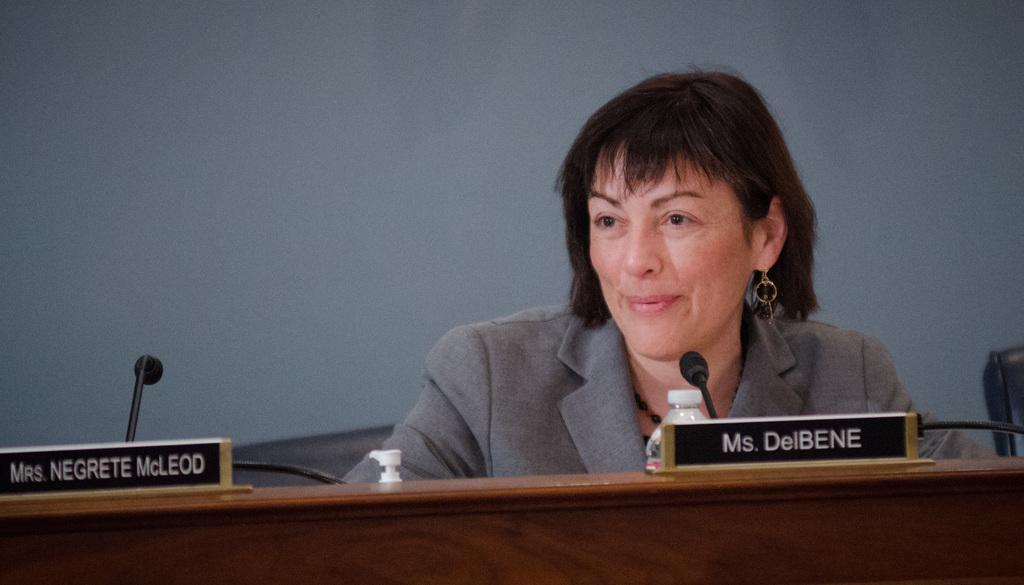What is the woman in the image doing? The woman is sitting and smiling in the image. What is the woman wearing? The woman is wearing a suit. What can be seen on the table in the image? There are name boards, microphones (mikes), and a bottle on the table. What is the color of the background in the image? The background of the image appears to be grey in color. Can you see any clovers on the table in the image? There are no clovers present on the table in the image. How does the woman mark her territory in the image? The woman is not marking her territory in the image; she is simply sitting and smiling. 